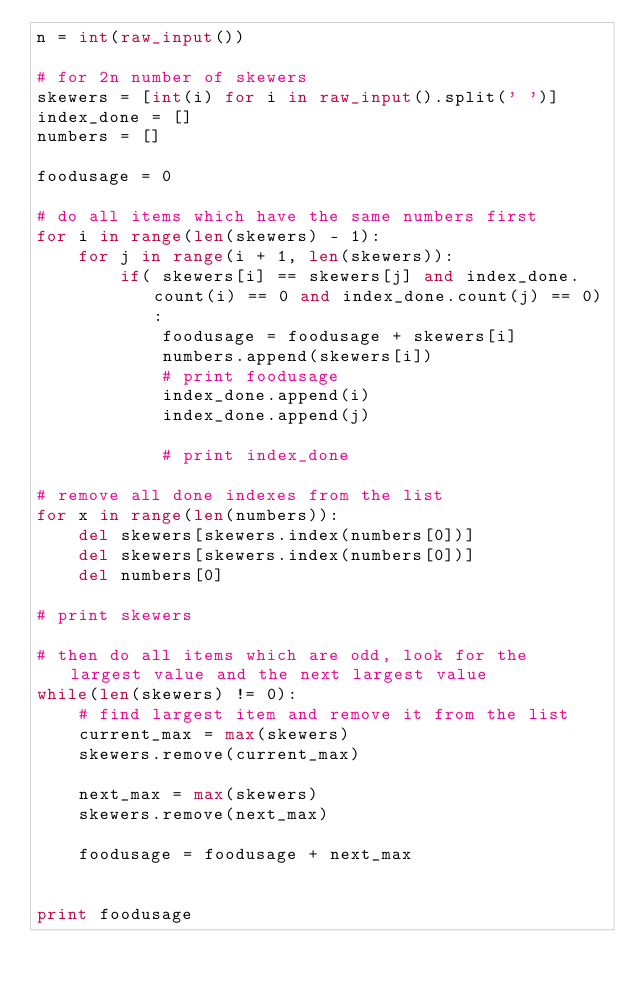<code> <loc_0><loc_0><loc_500><loc_500><_Python_>n = int(raw_input())

# for 2n number of skewers
skewers = [int(i) for i in raw_input().split(' ')]
index_done = []
numbers = []

foodusage = 0

# do all items which have the same numbers first
for i in range(len(skewers) - 1):
    for j in range(i + 1, len(skewers)):
        if( skewers[i] == skewers[j] and index_done.count(i) == 0 and index_done.count(j) == 0):
            foodusage = foodusage + skewers[i]
            numbers.append(skewers[i])
            # print foodusage
            index_done.append(i)
            index_done.append(j)

            # print index_done

# remove all done indexes from the list
for x in range(len(numbers)):
    del skewers[skewers.index(numbers[0])]
    del skewers[skewers.index(numbers[0])]
    del numbers[0]

# print skewers

# then do all items which are odd, look for the largest value and the next largest value
while(len(skewers) != 0):
    # find largest item and remove it from the list
    current_max = max(skewers)
    skewers.remove(current_max)

    next_max = max(skewers)
    skewers.remove(next_max)

    foodusage = foodusage + next_max
    

print foodusage</code> 